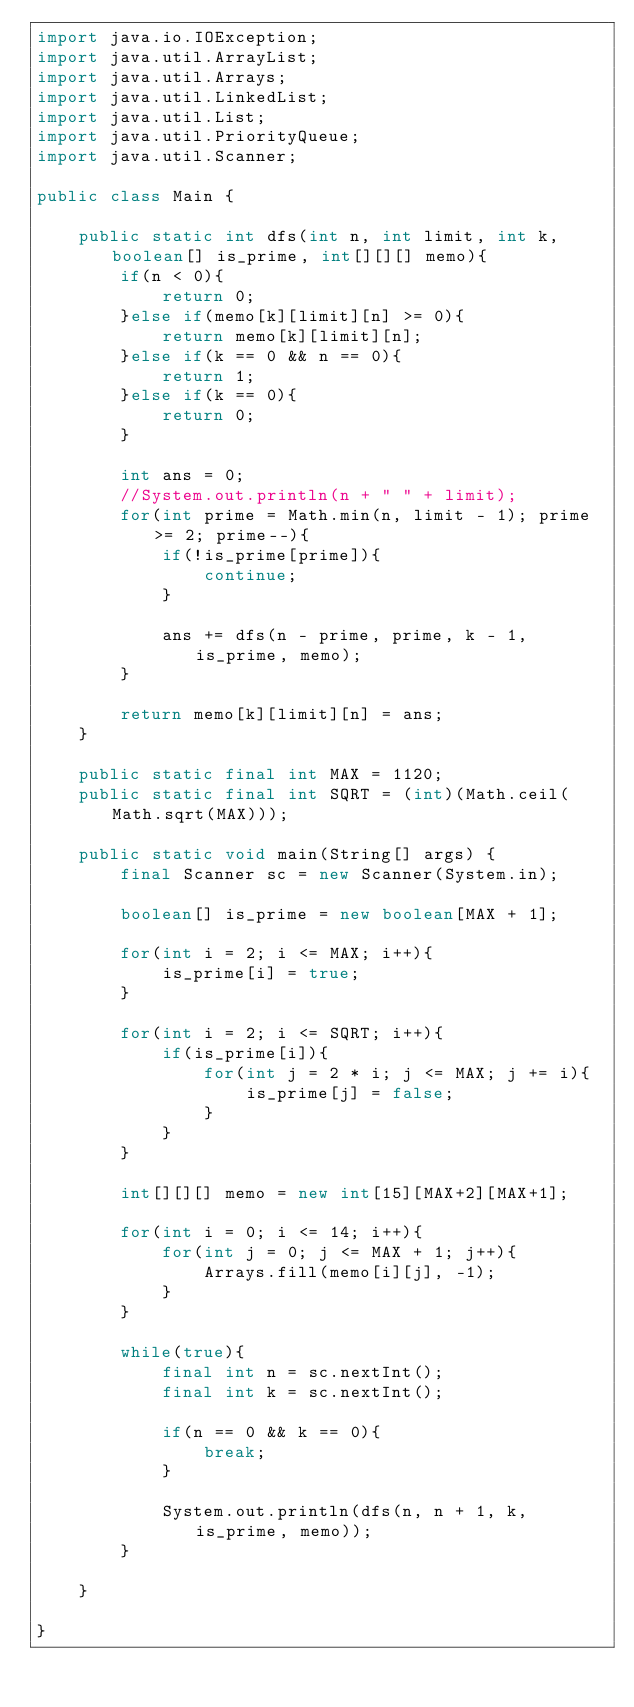<code> <loc_0><loc_0><loc_500><loc_500><_Java_>import java.io.IOException;
import java.util.ArrayList;
import java.util.Arrays;
import java.util.LinkedList;
import java.util.List;
import java.util.PriorityQueue;
import java.util.Scanner;

public class Main {

	public static int dfs(int n, int limit, int k, boolean[] is_prime, int[][][] memo){
		if(n < 0){
			return 0;
		}else if(memo[k][limit][n] >= 0){
			return memo[k][limit][n];
		}else if(k == 0 && n == 0){
			return 1;
		}else if(k == 0){
			return 0;
		}
		
		int ans = 0;
		//System.out.println(n + " " + limit);
		for(int prime = Math.min(n, limit - 1); prime >= 2; prime--){
			if(!is_prime[prime]){
				continue;
			}
			
			ans += dfs(n - prime, prime, k - 1, is_prime, memo);
		}
		
		return memo[k][limit][n] = ans;
	}
	
	public static final int MAX = 1120;
	public static final int SQRT = (int)(Math.ceil(Math.sqrt(MAX)));
	
	public static void main(String[] args) {
		final Scanner sc = new Scanner(System.in);

		boolean[] is_prime = new boolean[MAX + 1];
		
		for(int i = 2; i <= MAX; i++){
			is_prime[i] = true;
		}
		
		for(int i = 2; i <= SQRT; i++){
			if(is_prime[i]){
				for(int j = 2 * i; j <= MAX; j += i){
					is_prime[j] = false;
				}
			}
		}
		
		int[][][] memo = new int[15][MAX+2][MAX+1];
		
		for(int i = 0; i <= 14; i++){
			for(int j = 0; j <= MAX + 1; j++){
				Arrays.fill(memo[i][j], -1);
			}
		}
		
		while(true){
			final int n = sc.nextInt();
			final int k = sc.nextInt();
			
			if(n == 0 && k == 0){
				break;
			}
			
			System.out.println(dfs(n, n + 1, k, is_prime, memo));
		}
		
	}

}</code> 